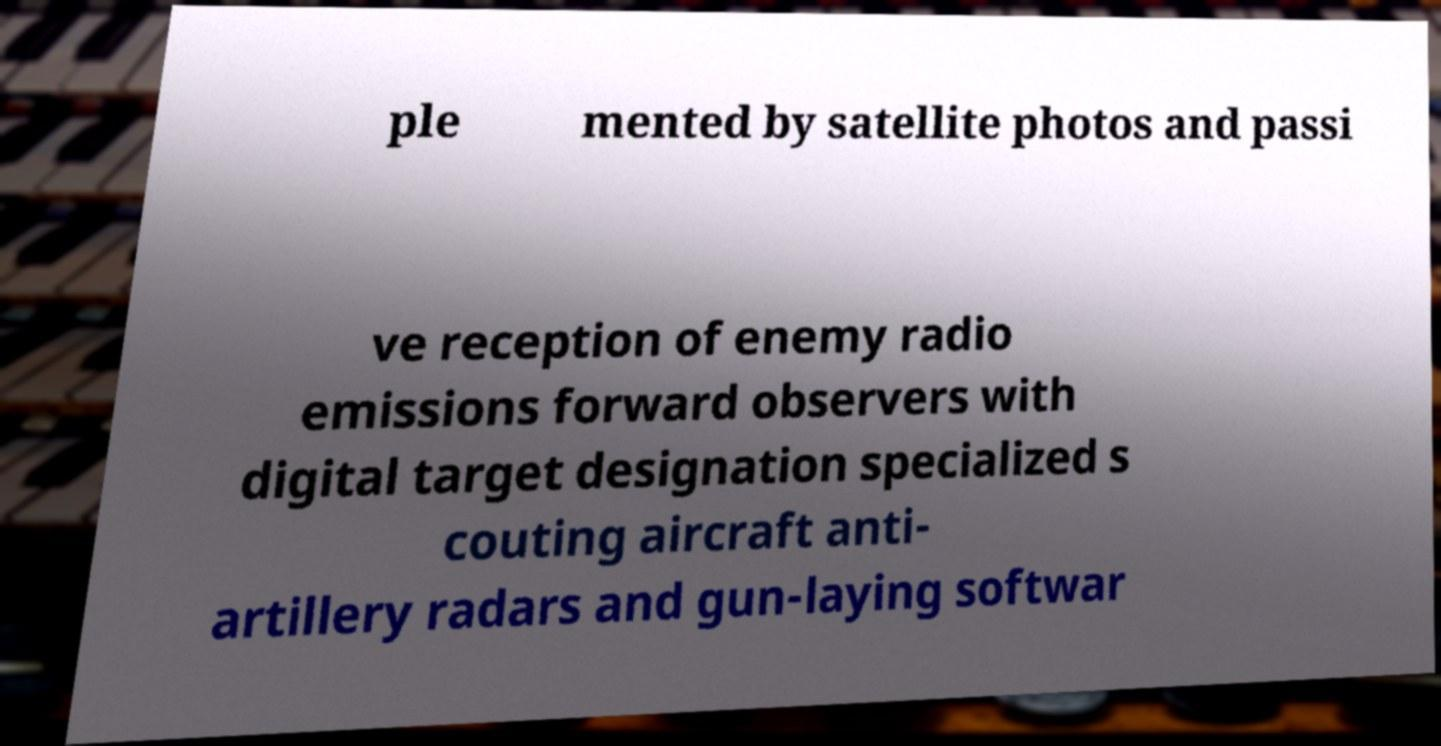I need the written content from this picture converted into text. Can you do that? ple mented by satellite photos and passi ve reception of enemy radio emissions forward observers with digital target designation specialized s couting aircraft anti- artillery radars and gun-laying softwar 